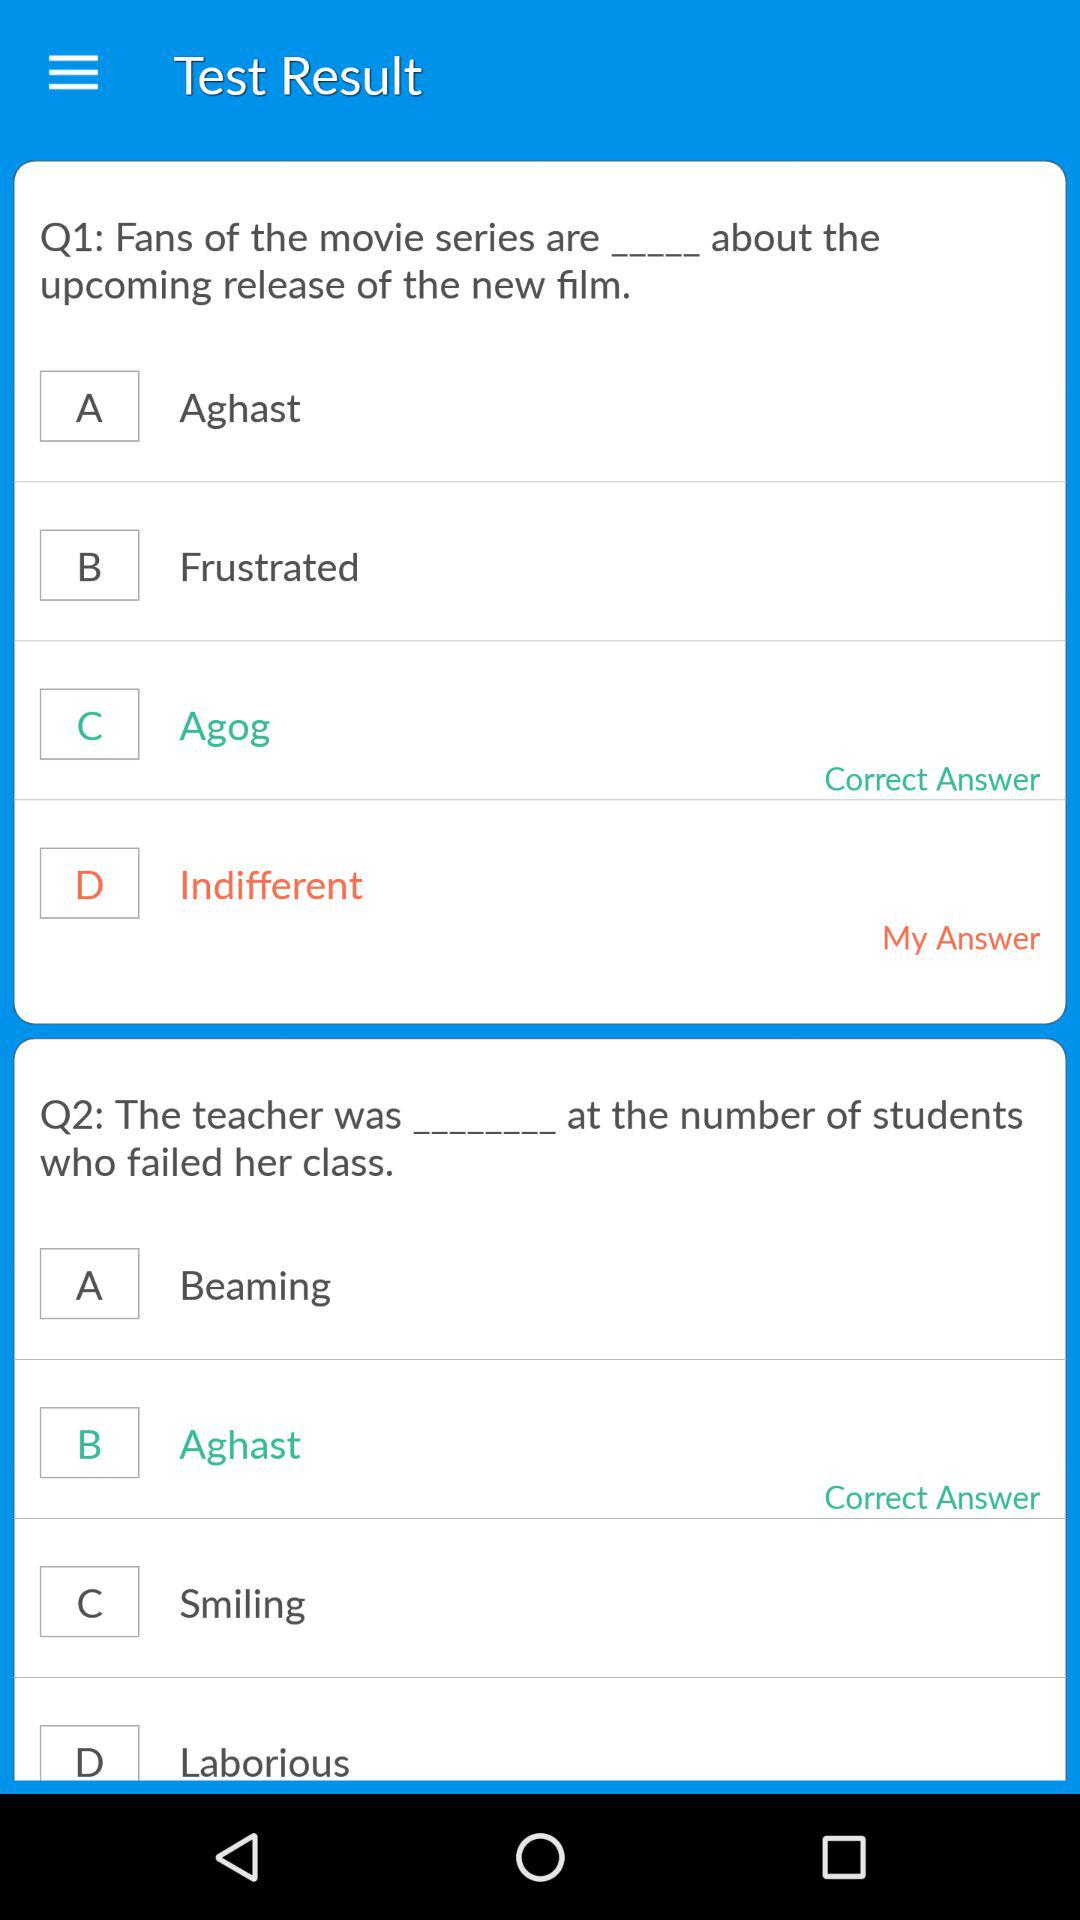What is the correct answer to the question about the teacher and her reaction towards failed students? The correct answer is "Aghast". 